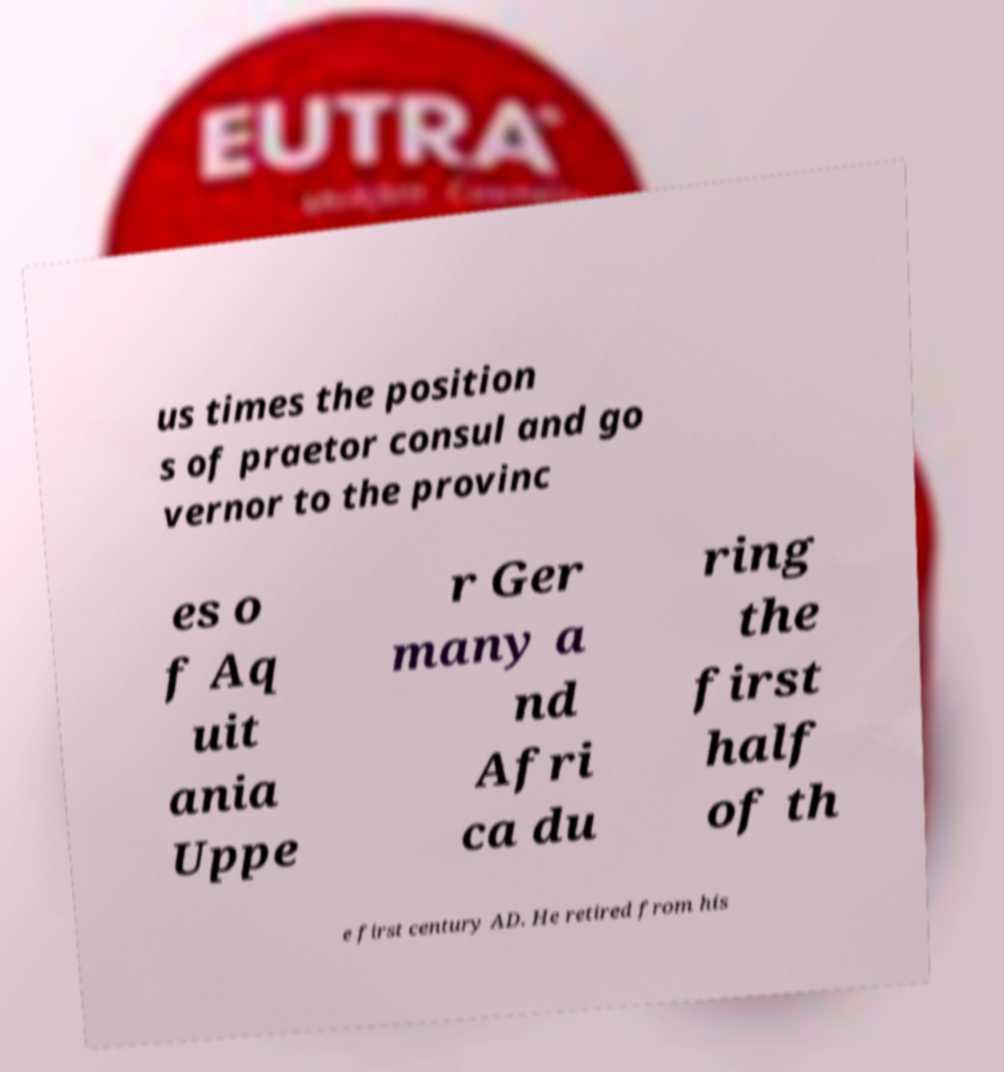There's text embedded in this image that I need extracted. Can you transcribe it verbatim? us times the position s of praetor consul and go vernor to the provinc es o f Aq uit ania Uppe r Ger many a nd Afri ca du ring the first half of th e first century AD. He retired from his 